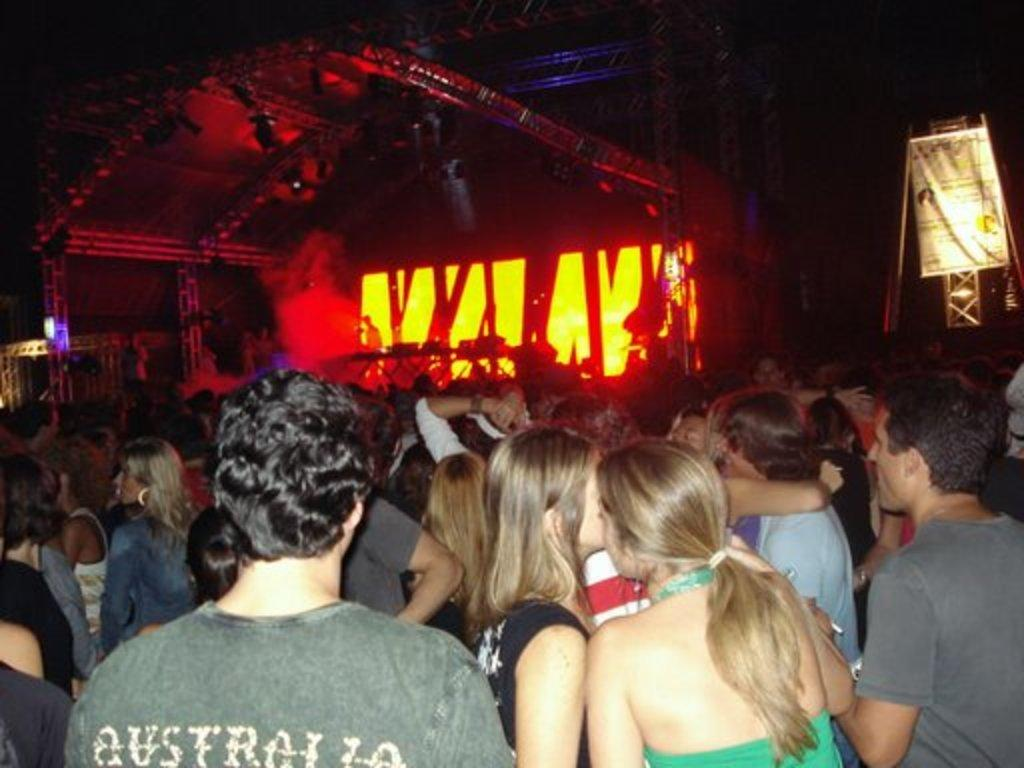What are the people in the image doing? The people in the image are standing in the center. What are the people wearing? The people are wearing different costumes. What can be seen in the background of the image? There is a banner and lights in the background, as well as other objects. What type of discovery was made by the people in the image? There is no indication in the image of a discovery being made, as the people are simply standing in different costumes. 